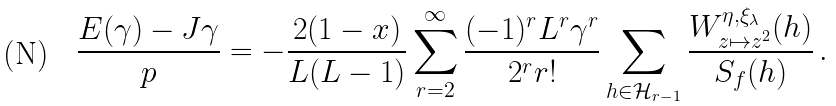Convert formula to latex. <formula><loc_0><loc_0><loc_500><loc_500>\frac { E ( \gamma ) - J \gamma } { p } = - \frac { 2 ( 1 - x ) } { L ( L - 1 ) } \sum _ { r = 2 } ^ { \infty } \frac { ( - 1 ) ^ { r } L ^ { r } \gamma ^ { r } } { 2 ^ { r } r ! } \sum _ { h \in \mathcal { H } _ { r - 1 } } \frac { W _ { z \mapsto z ^ { 2 } } ^ { \eta , \xi _ { \lambda } } ( h ) } { S _ { f } ( h ) } \, .</formula> 